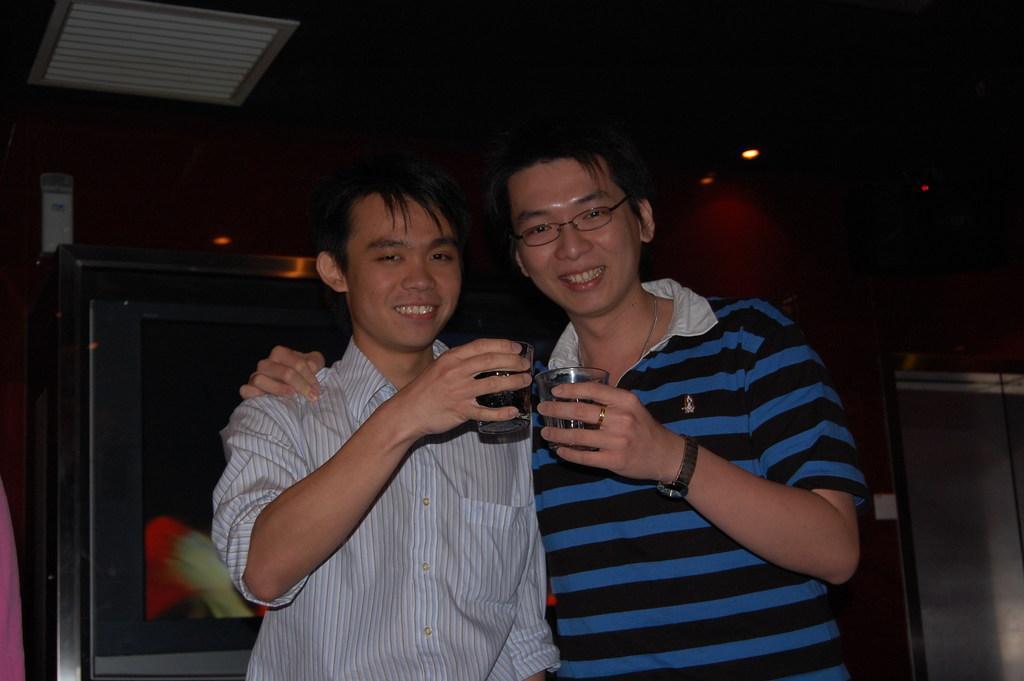Can you describe this image briefly? In this image, we can see two persons wearing clothes and holding glasses with their hands. 